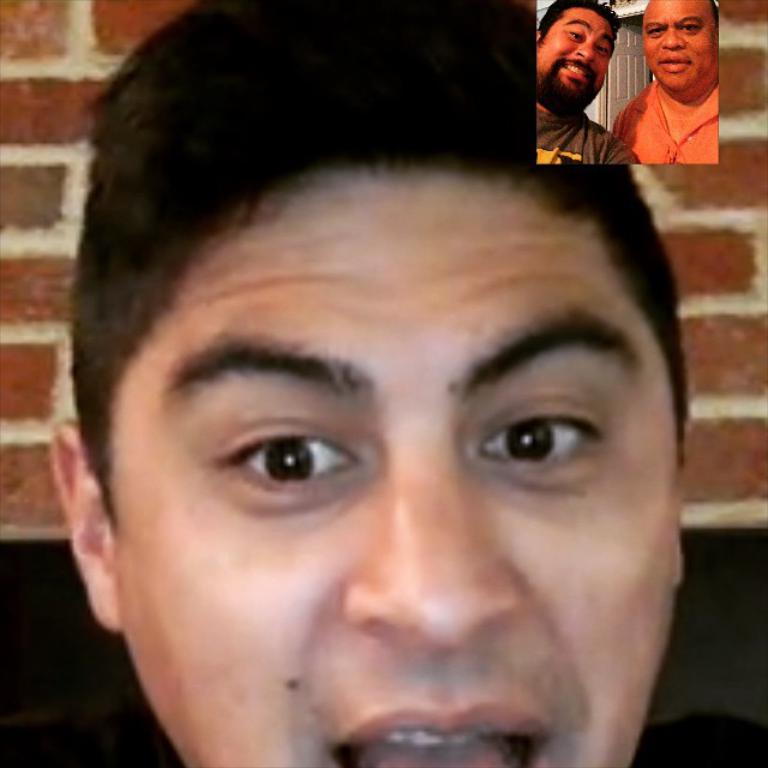What type of communication is happening in the image? The image is a screenshot of a video call. How many people are involved in the video call? There is one person calling two other persons. Where are the pictures of the other two persons located in the image? The pictures of the other two persons are on the top right of the image. What type of beam is holding up the ceiling in the image? There is no ceiling or beam present in the image, as it is a screenshot of a video call. What type of suit is the person on the left wearing in the image? There is no person on the left in the image, as the pictures of the other two persons are on the top right. 